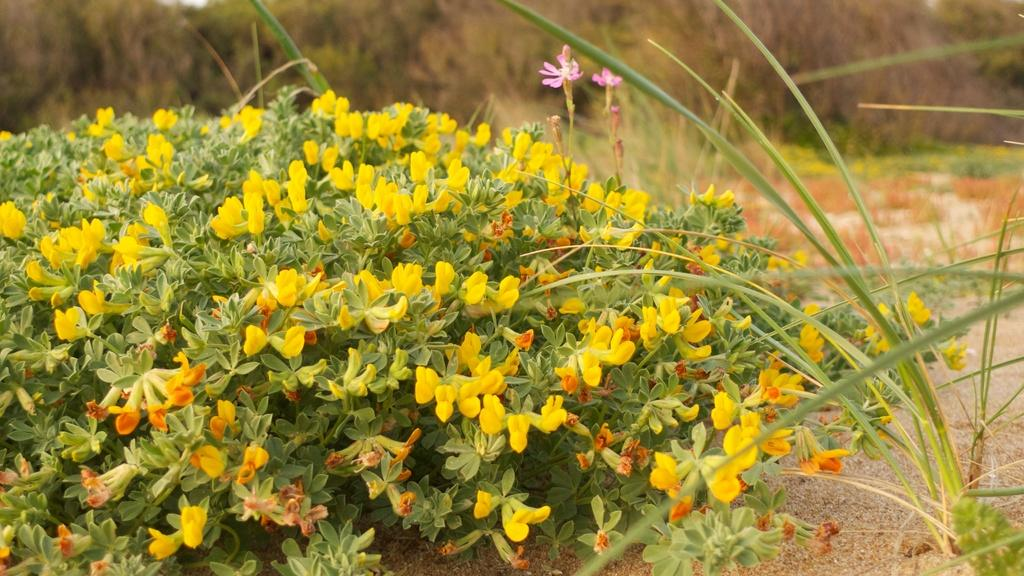What type of plants can be seen in the image? There are plants with flowers in the image. What can be seen on the right side of the image? There is grass on the right side of the image. What is visible in the background of the image? There are plants on the land in the background of the image. What type of behavior can be observed in the owl in the image? There is no owl present in the image, so it is not possible to observe any behavior. 